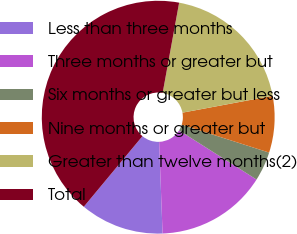Convert chart. <chart><loc_0><loc_0><loc_500><loc_500><pie_chart><fcel>Less than three months<fcel>Three months or greater but<fcel>Six months or greater but less<fcel>Nine months or greater but<fcel>Greater than twelve months(2)<fcel>Total<nl><fcel>11.63%<fcel>15.41%<fcel>4.08%<fcel>7.86%<fcel>19.18%<fcel>41.84%<nl></chart> 